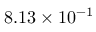Convert formula to latex. <formula><loc_0><loc_0><loc_500><loc_500>8 . 1 3 \times 1 0 ^ { - 1 }</formula> 